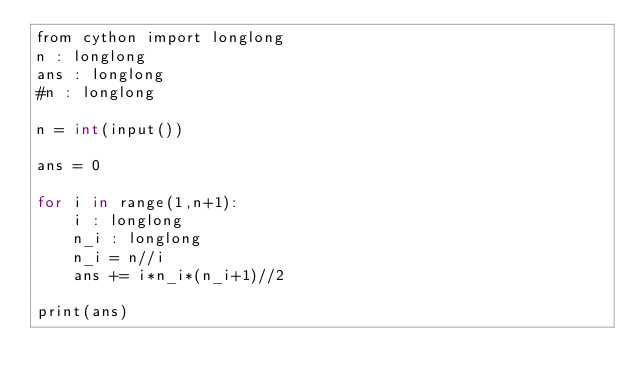<code> <loc_0><loc_0><loc_500><loc_500><_Cython_>from cython import longlong
n : longlong
ans : longlong
#n : longlong

n = int(input())

ans = 0

for i in range(1,n+1):
    i : longlong
    n_i : longlong
    n_i = n//i
    ans += i*n_i*(n_i+1)//2
    
print(ans)</code> 